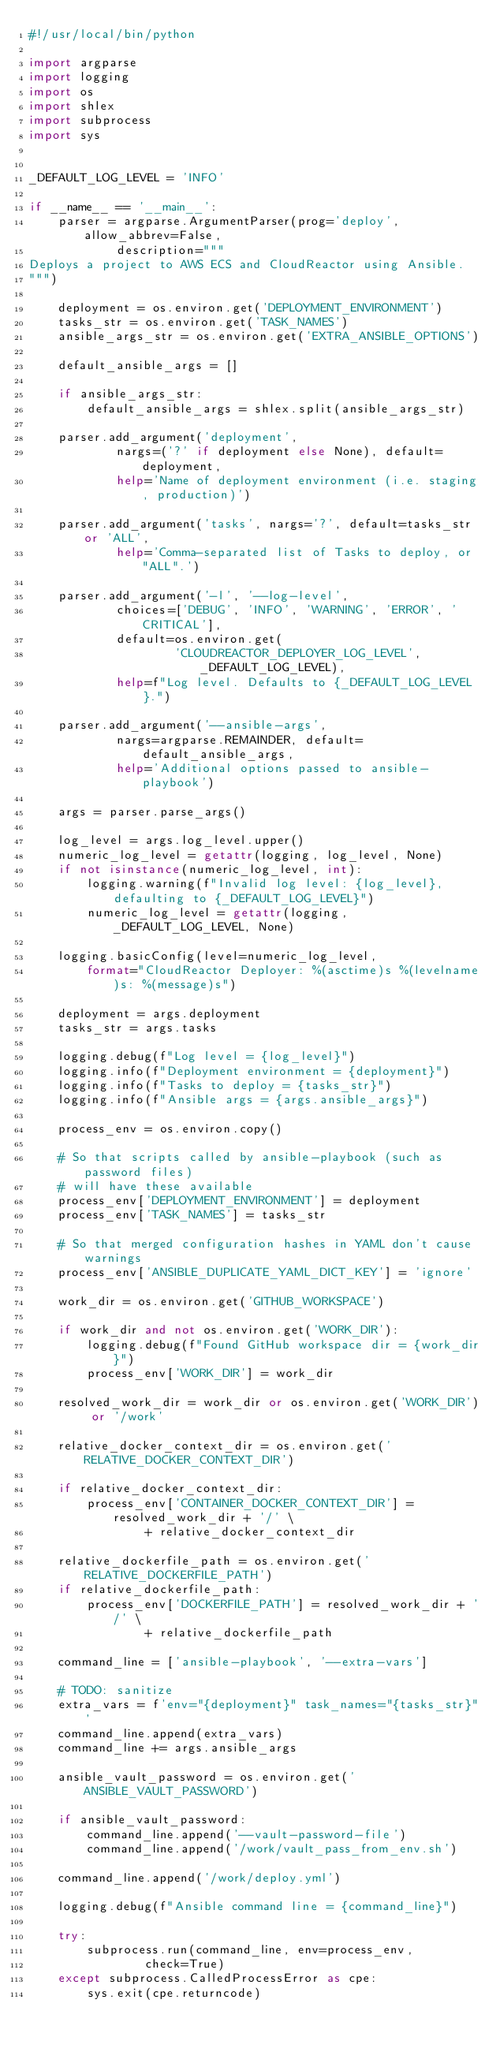<code> <loc_0><loc_0><loc_500><loc_500><_Python_>#!/usr/local/bin/python

import argparse
import logging
import os
import shlex
import subprocess
import sys


_DEFAULT_LOG_LEVEL = 'INFO'

if __name__ == '__main__':
    parser = argparse.ArgumentParser(prog='deploy', allow_abbrev=False,
            description="""
Deploys a project to AWS ECS and CloudReactor using Ansible.
""")

    deployment = os.environ.get('DEPLOYMENT_ENVIRONMENT')
    tasks_str = os.environ.get('TASK_NAMES')
    ansible_args_str = os.environ.get('EXTRA_ANSIBLE_OPTIONS')

    default_ansible_args = []

    if ansible_args_str:
        default_ansible_args = shlex.split(ansible_args_str)

    parser.add_argument('deployment',
            nargs=('?' if deployment else None), default=deployment,
            help='Name of deployment environment (i.e. staging, production)')

    parser.add_argument('tasks', nargs='?', default=tasks_str or 'ALL',
            help='Comma-separated list of Tasks to deploy, or "ALL".')

    parser.add_argument('-l', '--log-level',
            choices=['DEBUG', 'INFO', 'WARNING', 'ERROR', 'CRITICAL'],
            default=os.environ.get(
                    'CLOUDREACTOR_DEPLOYER_LOG_LEVEL', _DEFAULT_LOG_LEVEL),
            help=f"Log level. Defaults to {_DEFAULT_LOG_LEVEL}.")

    parser.add_argument('--ansible-args',
            nargs=argparse.REMAINDER, default=default_ansible_args,
            help='Additional options passed to ansible-playbook')

    args = parser.parse_args()

    log_level = args.log_level.upper()
    numeric_log_level = getattr(logging, log_level, None)
    if not isinstance(numeric_log_level, int):
        logging.warning(f"Invalid log level: {log_level}, defaulting to {_DEFAULT_LOG_LEVEL}")
        numeric_log_level = getattr(logging, _DEFAULT_LOG_LEVEL, None)

    logging.basicConfig(level=numeric_log_level,
        format="CloudReactor Deployer: %(asctime)s %(levelname)s: %(message)s")

    deployment = args.deployment
    tasks_str = args.tasks

    logging.debug(f"Log level = {log_level}")
    logging.info(f"Deployment environment = {deployment}")
    logging.info(f"Tasks to deploy = {tasks_str}")
    logging.info(f"Ansible args = {args.ansible_args}")

    process_env = os.environ.copy()

    # So that scripts called by ansible-playbook (such as password files)
    # will have these available
    process_env['DEPLOYMENT_ENVIRONMENT'] = deployment
    process_env['TASK_NAMES'] = tasks_str

    # So that merged configuration hashes in YAML don't cause warnings
    process_env['ANSIBLE_DUPLICATE_YAML_DICT_KEY'] = 'ignore'

    work_dir = os.environ.get('GITHUB_WORKSPACE')

    if work_dir and not os.environ.get('WORK_DIR'):
        logging.debug(f"Found GitHub workspace dir = {work_dir}")
        process_env['WORK_DIR'] = work_dir

    resolved_work_dir = work_dir or os.environ.get('WORK_DIR') or '/work'

    relative_docker_context_dir = os.environ.get('RELATIVE_DOCKER_CONTEXT_DIR')

    if relative_docker_context_dir:
        process_env['CONTAINER_DOCKER_CONTEXT_DIR'] = resolved_work_dir + '/' \
                + relative_docker_context_dir

    relative_dockerfile_path = os.environ.get('RELATIVE_DOCKERFILE_PATH')
    if relative_dockerfile_path:
        process_env['DOCKERFILE_PATH'] = resolved_work_dir + '/' \
                + relative_dockerfile_path

    command_line = ['ansible-playbook', '--extra-vars']

    # TODO: sanitize
    extra_vars = f'env="{deployment}" task_names="{tasks_str}"'
    command_line.append(extra_vars)
    command_line += args.ansible_args

    ansible_vault_password = os.environ.get('ANSIBLE_VAULT_PASSWORD')

    if ansible_vault_password:
        command_line.append('--vault-password-file')
        command_line.append('/work/vault_pass_from_env.sh')

    command_line.append('/work/deploy.yml')

    logging.debug(f"Ansible command line = {command_line}")

    try:
        subprocess.run(command_line, env=process_env,
                check=True)
    except subprocess.CalledProcessError as cpe:
        sys.exit(cpe.returncode)
</code> 